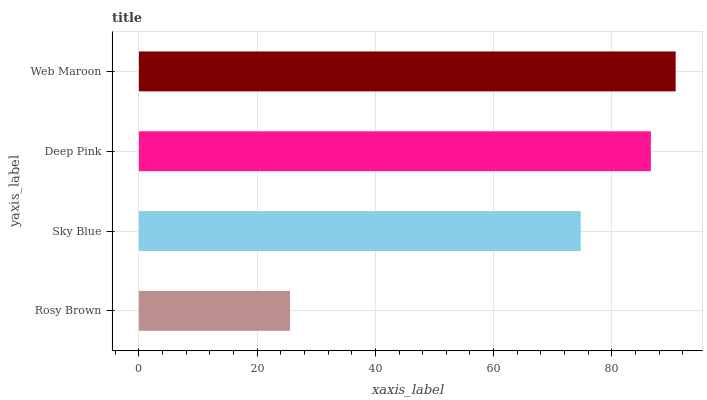Is Rosy Brown the minimum?
Answer yes or no. Yes. Is Web Maroon the maximum?
Answer yes or no. Yes. Is Sky Blue the minimum?
Answer yes or no. No. Is Sky Blue the maximum?
Answer yes or no. No. Is Sky Blue greater than Rosy Brown?
Answer yes or no. Yes. Is Rosy Brown less than Sky Blue?
Answer yes or no. Yes. Is Rosy Brown greater than Sky Blue?
Answer yes or no. No. Is Sky Blue less than Rosy Brown?
Answer yes or no. No. Is Deep Pink the high median?
Answer yes or no. Yes. Is Sky Blue the low median?
Answer yes or no. Yes. Is Sky Blue the high median?
Answer yes or no. No. Is Deep Pink the low median?
Answer yes or no. No. 